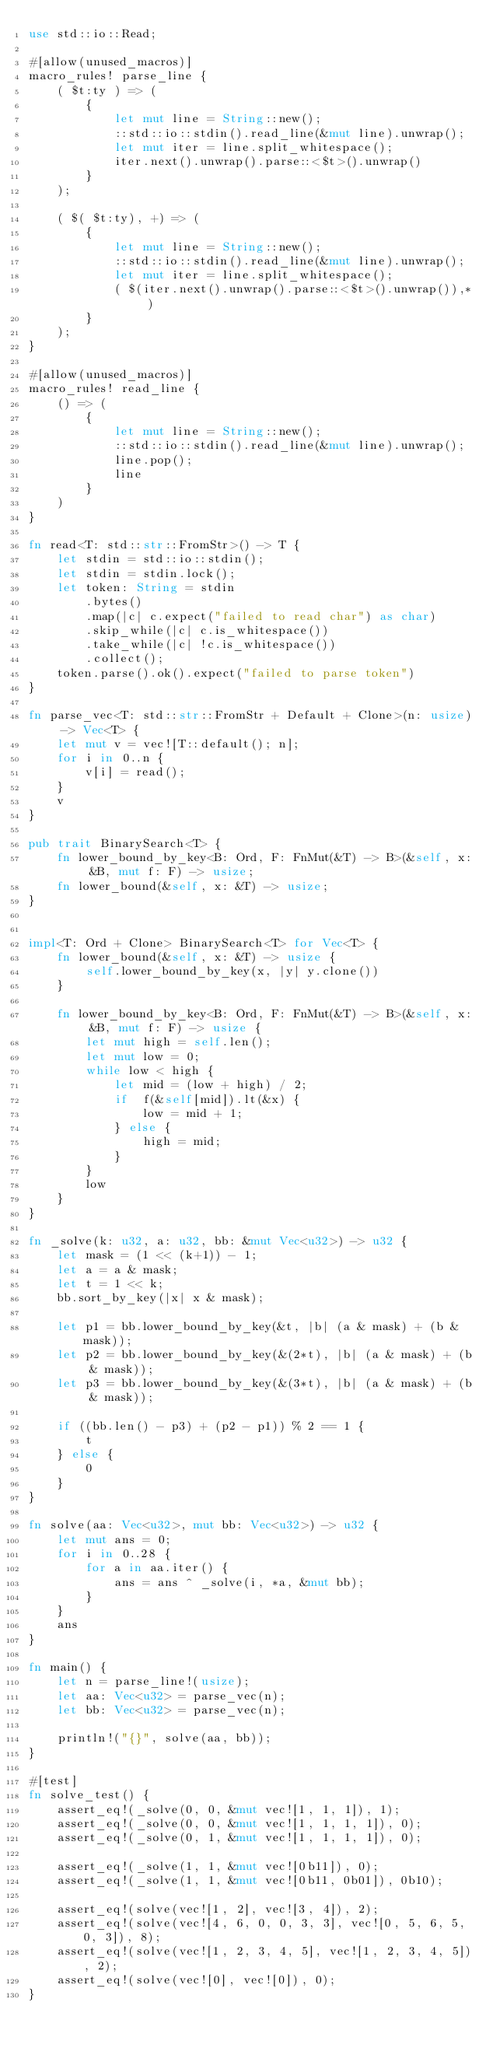<code> <loc_0><loc_0><loc_500><loc_500><_Rust_>use std::io::Read;

#[allow(unused_macros)]
macro_rules! parse_line {
    ( $t:ty ) => (
        {
            let mut line = String::new();
            ::std::io::stdin().read_line(&mut line).unwrap();
            let mut iter = line.split_whitespace();
            iter.next().unwrap().parse::<$t>().unwrap()
        }
    );

    ( $( $t:ty), +) => (
        {
            let mut line = String::new();
            ::std::io::stdin().read_line(&mut line).unwrap();
            let mut iter = line.split_whitespace();
            ( $(iter.next().unwrap().parse::<$t>().unwrap()),* )
        }
    );
}

#[allow(unused_macros)]
macro_rules! read_line {
    () => (
        {
            let mut line = String::new();
            ::std::io::stdin().read_line(&mut line).unwrap();
            line.pop();
            line
        }
    )
}

fn read<T: std::str::FromStr>() -> T {
    let stdin = std::io::stdin();
    let stdin = stdin.lock();
    let token: String = stdin
        .bytes()
        .map(|c| c.expect("failed to read char") as char)
        .skip_while(|c| c.is_whitespace())
        .take_while(|c| !c.is_whitespace())
        .collect();
    token.parse().ok().expect("failed to parse token")
}

fn parse_vec<T: std::str::FromStr + Default + Clone>(n: usize) -> Vec<T> {
    let mut v = vec![T::default(); n];
    for i in 0..n {
        v[i] = read();
    }
    v
}

pub trait BinarySearch<T> {
    fn lower_bound_by_key<B: Ord, F: FnMut(&T) -> B>(&self, x: &B, mut f: F) -> usize;
    fn lower_bound(&self, x: &T) -> usize;
}


impl<T: Ord + Clone> BinarySearch<T> for Vec<T> {
    fn lower_bound(&self, x: &T) -> usize {
        self.lower_bound_by_key(x, |y| y.clone())
    }

    fn lower_bound_by_key<B: Ord, F: FnMut(&T) -> B>(&self, x: &B, mut f: F) -> usize {
        let mut high = self.len();
        let mut low = 0;
        while low < high {
            let mid = (low + high) / 2;
            if  f(&self[mid]).lt(&x) {
                low = mid + 1;
            } else {
                high = mid;
            }
        }
        low
    }
}

fn _solve(k: u32, a: u32, bb: &mut Vec<u32>) -> u32 {
    let mask = (1 << (k+1)) - 1;
    let a = a & mask;
    let t = 1 << k;
    bb.sort_by_key(|x| x & mask);

    let p1 = bb.lower_bound_by_key(&t, |b| (a & mask) + (b & mask));
    let p2 = bb.lower_bound_by_key(&(2*t), |b| (a & mask) + (b & mask));
    let p3 = bb.lower_bound_by_key(&(3*t), |b| (a & mask) + (b & mask));

    if ((bb.len() - p3) + (p2 - p1)) % 2 == 1 {
        t
    } else {
        0
    }
}

fn solve(aa: Vec<u32>, mut bb: Vec<u32>) -> u32 {
    let mut ans = 0;
    for i in 0..28 {
        for a in aa.iter() {
            ans = ans ^ _solve(i, *a, &mut bb);
        }
    }
    ans
}

fn main() {
    let n = parse_line!(usize);
    let aa: Vec<u32> = parse_vec(n);
    let bb: Vec<u32> = parse_vec(n);

    println!("{}", solve(aa, bb));
}

#[test]
fn solve_test() {
    assert_eq!(_solve(0, 0, &mut vec![1, 1, 1]), 1);
    assert_eq!(_solve(0, 0, &mut vec![1, 1, 1, 1]), 0);
    assert_eq!(_solve(0, 1, &mut vec![1, 1, 1, 1]), 0);

    assert_eq!(_solve(1, 1, &mut vec![0b11]), 0);
    assert_eq!(_solve(1, 1, &mut vec![0b11, 0b01]), 0b10);

    assert_eq!(solve(vec![1, 2], vec![3, 4]), 2);
    assert_eq!(solve(vec![4, 6, 0, 0, 3, 3], vec![0, 5, 6, 5, 0, 3]), 8);
    assert_eq!(solve(vec![1, 2, 3, 4, 5], vec![1, 2, 3, 4, 5]), 2);
    assert_eq!(solve(vec![0], vec![0]), 0);
}
</code> 